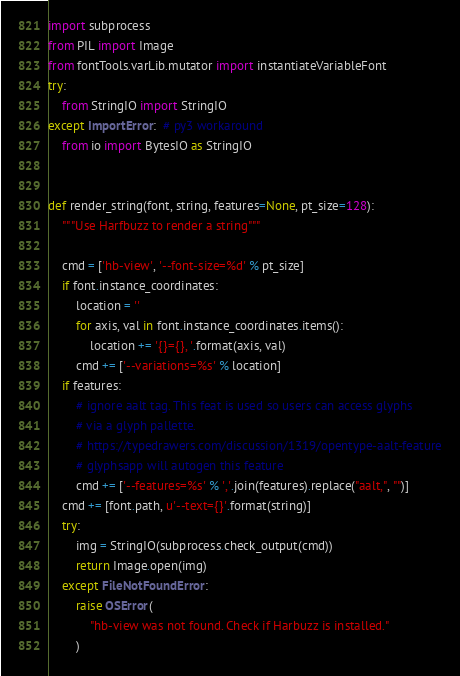<code> <loc_0><loc_0><loc_500><loc_500><_Python_>import subprocess
from PIL import Image
from fontTools.varLib.mutator import instantiateVariableFont
try:
    from StringIO import StringIO
except ImportError:  # py3 workaround
    from io import BytesIO as StringIO


def render_string(font, string, features=None, pt_size=128):
    """Use Harfbuzz to render a string"""

    cmd = ['hb-view', '--font-size=%d' % pt_size]
    if font.instance_coordinates:
        location = ''
        for axis, val in font.instance_coordinates.items():
            location += '{}={}, '.format(axis, val)
        cmd += ['--variations=%s' % location]
    if features:
        # ignore aalt tag. This feat is used so users can access glyphs
        # via a glyph pallette.
        # https://typedrawers.com/discussion/1319/opentype-aalt-feature
        # glyphsapp will autogen this feature
        cmd += ['--features=%s' % ','.join(features).replace("aalt,", "")]
    cmd += [font.path, u'--text={}'.format(string)]
    try:
        img = StringIO(subprocess.check_output(cmd))
        return Image.open(img)
    except FileNotFoundError:
        raise OSError(
            "hb-view was not found. Check if Harbuzz is installed."
        )

</code> 